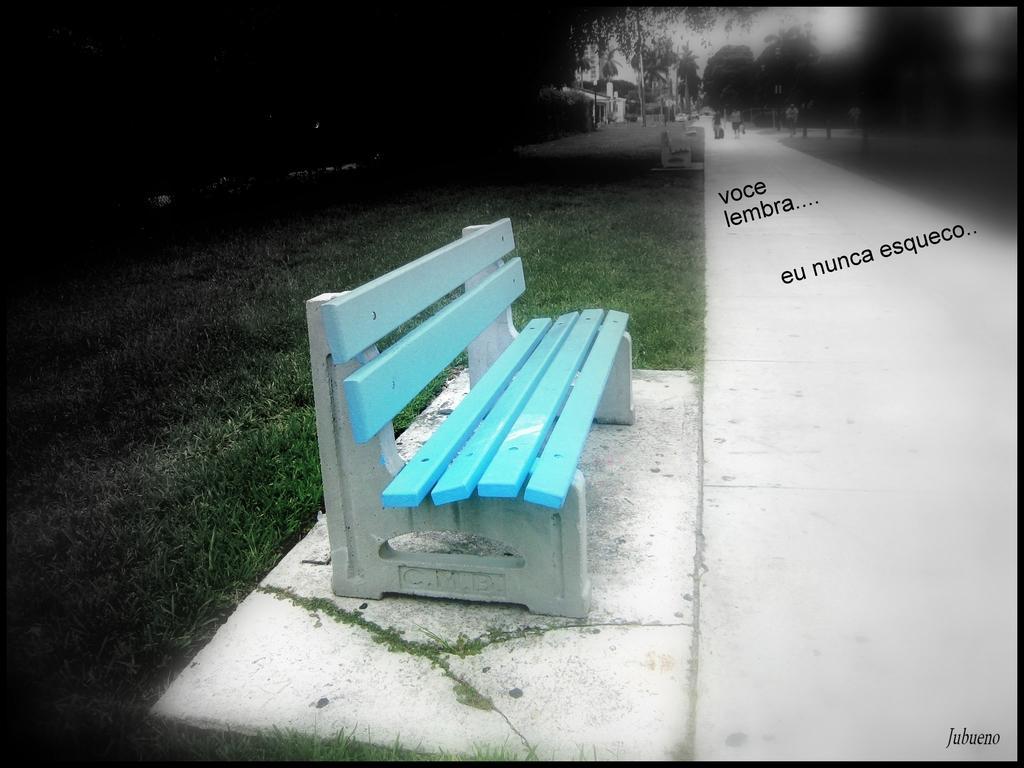Can you describe this image briefly? In this image we can see a bench. On the right side of the image, we can see a road. On the left side of the image, we can see grassy land. At the top of the image, we can see trees and the sky. 